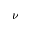<formula> <loc_0><loc_0><loc_500><loc_500>\nu</formula> 